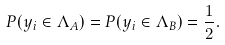Convert formula to latex. <formula><loc_0><loc_0><loc_500><loc_500>P ( y _ { i } \in \Lambda _ { A } ) = P ( y _ { i } \in \Lambda _ { B } ) = \frac { 1 } { 2 } .</formula> 